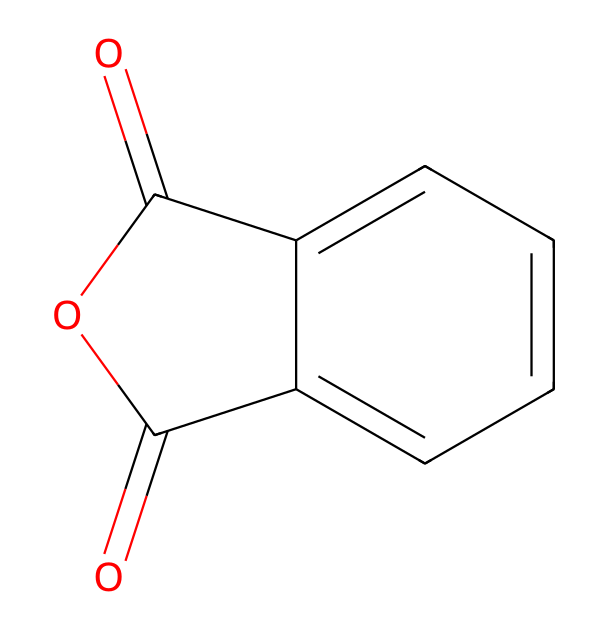What is the name of this chemical? The structure shown corresponds to phthalic anhydride, which is commonly used in various industrial applications and can be identified by the presence of an anhydride functional group along with a benzene ring.
Answer: phthalic anhydride How many carbon atoms are in this compound? By analyzing the SMILES representation, we identify six carbon atoms from the benzene ring and two additional carbon atoms from the carbonyls. Therefore, the total number of carbon atoms is eight.
Answer: 8 What type of functional group does phthalic anhydride feature? The presence of the cyclic imide structure in the chemical indicates that it contains an anhydride functional group, which is characteristic of acid anhydrides.
Answer: anhydride What is the total number of oxygen atoms in this compound? Looking at the structure, there are three oxygen atoms present: two in the carbonyl groups and one in the cyclic anhydride structure. Thus, the total count of oxygen atoms is three.
Answer: 3 Can phthalic anhydride participate in hydrolysis reactions? Given that phthalic anhydride includes the anhydride functional group, it is capable of participating in hydrolysis reactions, where it reacts with water to form phthalic acid.
Answer: yes What is the degree of unsaturation in phthalic anhydride? The structure contains a benzene ring, indicating significant unsaturation, along with the two carbonyls, which also contribute to unsaturation. The degree of unsaturation can be calculated, leading to the conclusion of four double bonds.
Answer: 4 